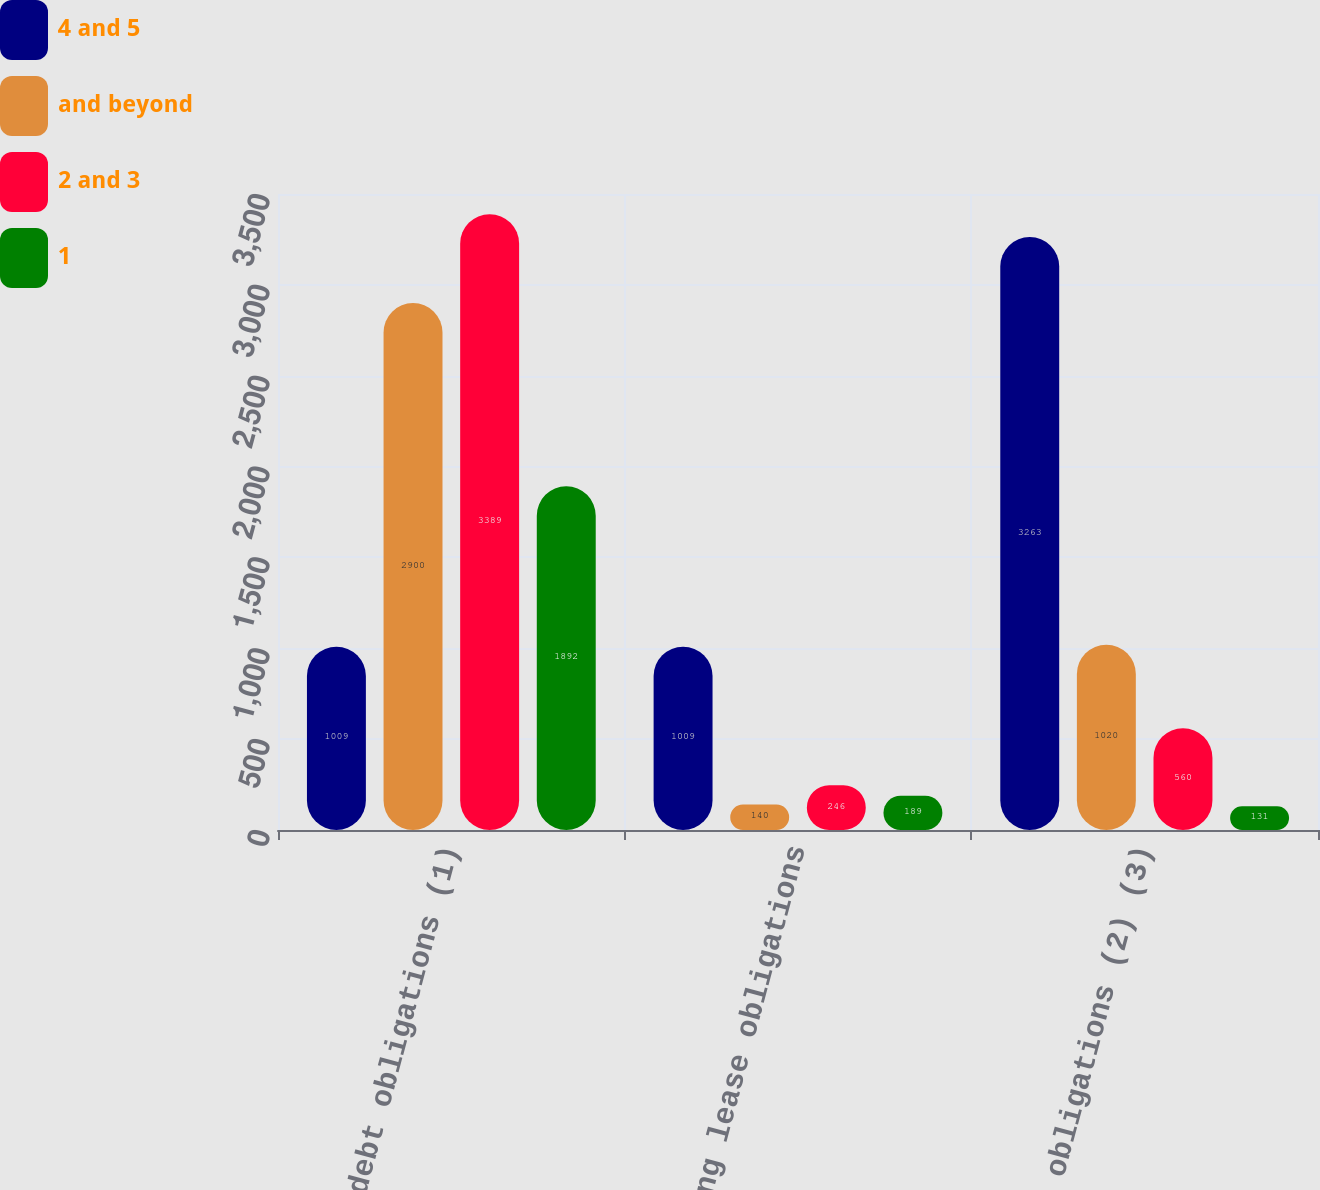<chart> <loc_0><loc_0><loc_500><loc_500><stacked_bar_chart><ecel><fcel>Long-term debt obligations (1)<fcel>Operating lease obligations<fcel>Purchase obligations (2) (3)<nl><fcel>4 and 5<fcel>1009<fcel>1009<fcel>3263<nl><fcel>and beyond<fcel>2900<fcel>140<fcel>1020<nl><fcel>2 and 3<fcel>3389<fcel>246<fcel>560<nl><fcel>1<fcel>1892<fcel>189<fcel>131<nl></chart> 